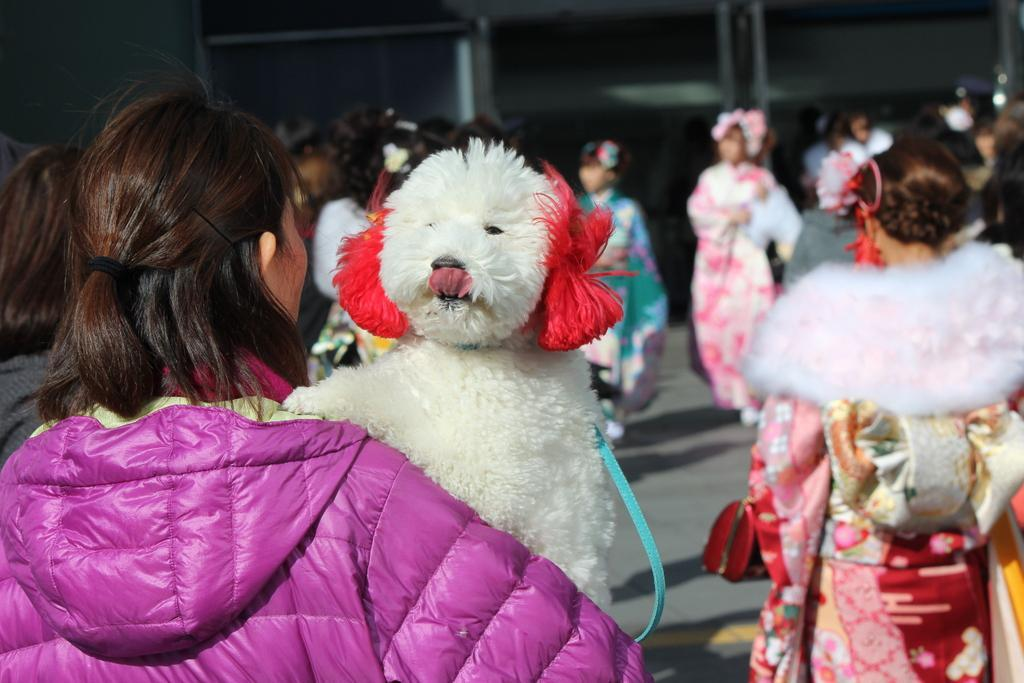How many people are in the image? There are people standing in the image. Can you describe the presence of any animals in the image? Yes, there is a dog in the image. What type of bubble can be seen in the image? There is no bubble present in the image. Are the people in the image engaged in an argument? The image does not show any signs of an argument between the people. 